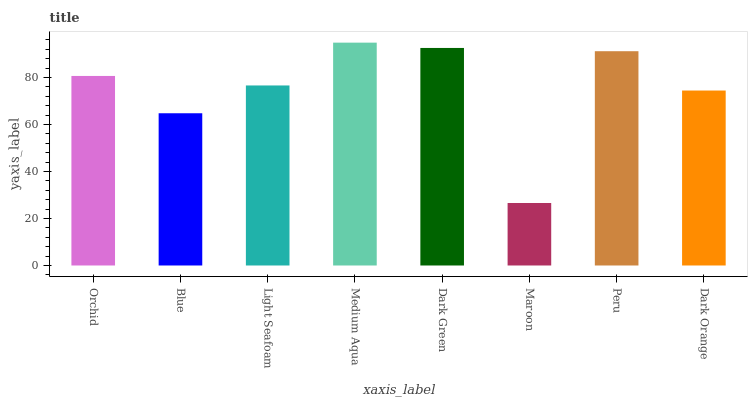Is Maroon the minimum?
Answer yes or no. Yes. Is Medium Aqua the maximum?
Answer yes or no. Yes. Is Blue the minimum?
Answer yes or no. No. Is Blue the maximum?
Answer yes or no. No. Is Orchid greater than Blue?
Answer yes or no. Yes. Is Blue less than Orchid?
Answer yes or no. Yes. Is Blue greater than Orchid?
Answer yes or no. No. Is Orchid less than Blue?
Answer yes or no. No. Is Orchid the high median?
Answer yes or no. Yes. Is Light Seafoam the low median?
Answer yes or no. Yes. Is Maroon the high median?
Answer yes or no. No. Is Medium Aqua the low median?
Answer yes or no. No. 